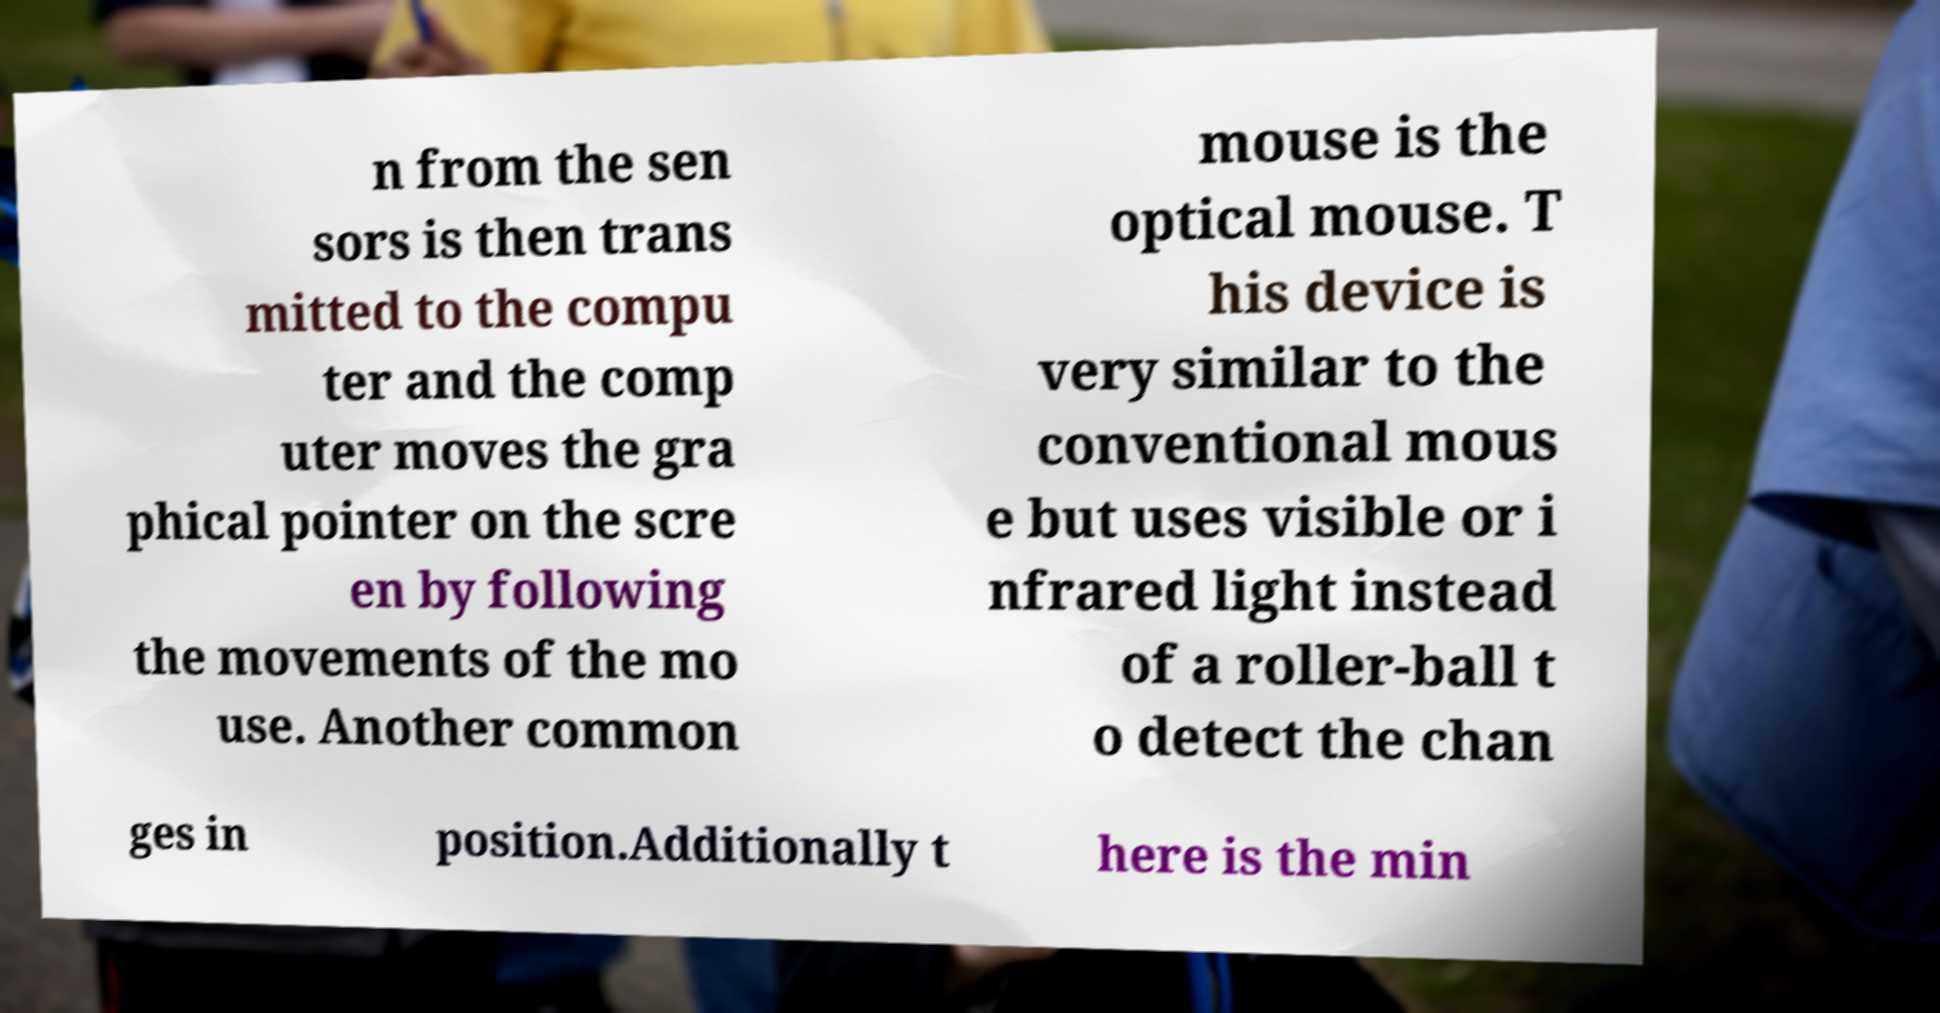I need the written content from this picture converted into text. Can you do that? n from the sen sors is then trans mitted to the compu ter and the comp uter moves the gra phical pointer on the scre en by following the movements of the mo use. Another common mouse is the optical mouse. T his device is very similar to the conventional mous e but uses visible or i nfrared light instead of a roller-ball t o detect the chan ges in position.Additionally t here is the min 